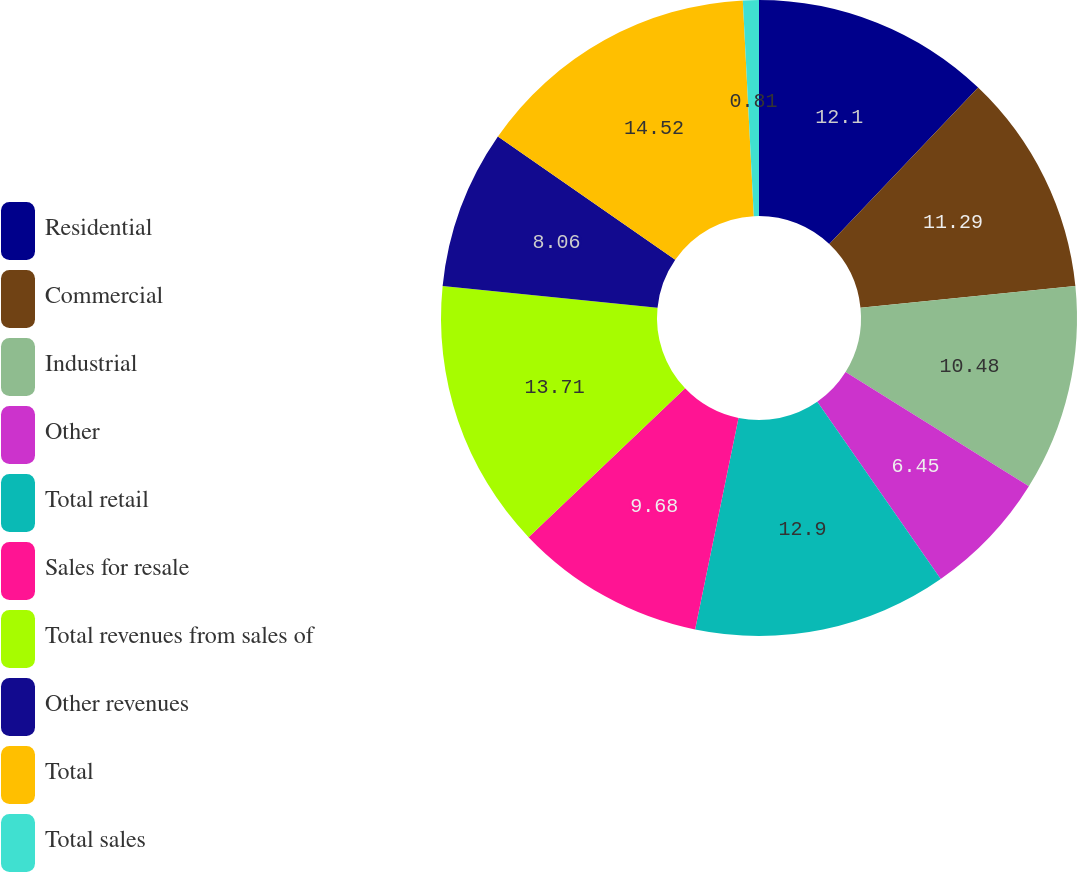<chart> <loc_0><loc_0><loc_500><loc_500><pie_chart><fcel>Residential<fcel>Commercial<fcel>Industrial<fcel>Other<fcel>Total retail<fcel>Sales for resale<fcel>Total revenues from sales of<fcel>Other revenues<fcel>Total<fcel>Total sales<nl><fcel>12.1%<fcel>11.29%<fcel>10.48%<fcel>6.45%<fcel>12.9%<fcel>9.68%<fcel>13.71%<fcel>8.06%<fcel>14.52%<fcel>0.81%<nl></chart> 